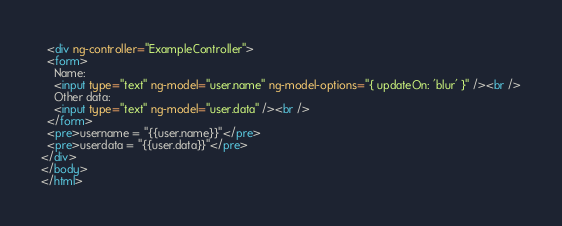Convert code to text. <code><loc_0><loc_0><loc_500><loc_500><_HTML_>  <div ng-controller="ExampleController">
  <form>
    Name:
    <input type="text" ng-model="user.name" ng-model-options="{ updateOn: 'blur' }" /><br />
    Other data:
    <input type="text" ng-model="user.data" /><br />
  </form>
  <pre>username = "{{user.name}}"</pre>
  <pre>userdata = "{{user.data}}"</pre>
</div>
</body>
</html></code> 